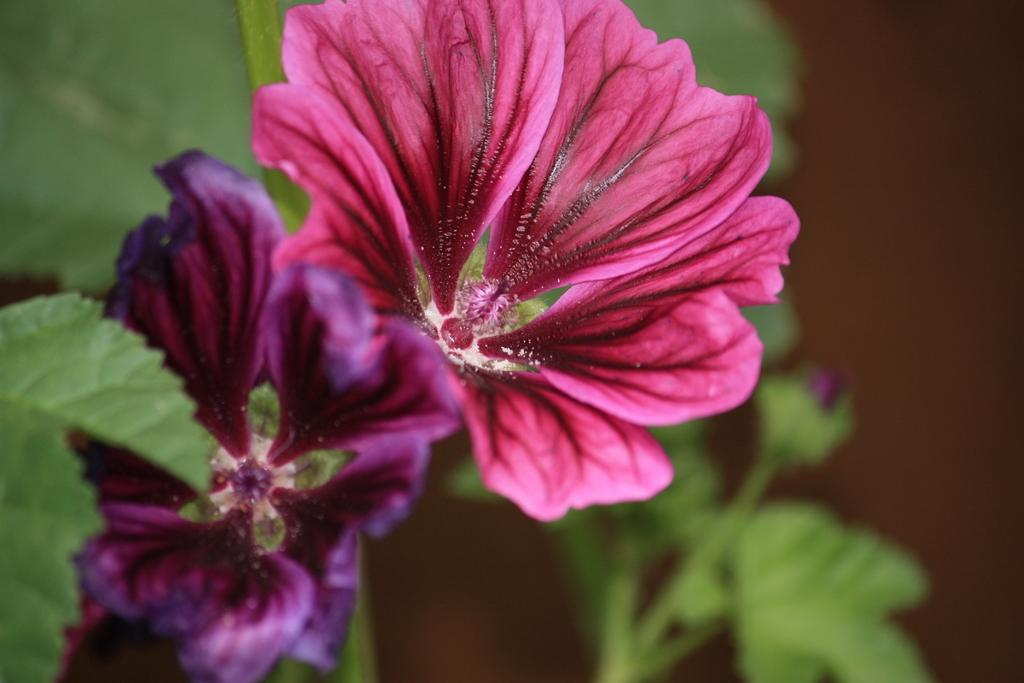What type of plant life can be seen in the image? There are flowers and leaves in the image. Can you describe the background of the image? The background of the image is blurry. What type of star can be seen in the image? There is no star present in the image; it features flowers and leaves with a blurry background. 